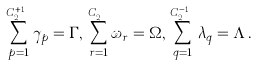<formula> <loc_0><loc_0><loc_500><loc_500>\sum _ { p = 1 } ^ { C _ { 2 N } ^ { x + 1 } } \gamma _ { p } = \Gamma , \, \sum _ { r = 1 } ^ { C _ { 2 N } ^ { x } } \omega _ { r } = \Omega , \, \sum _ { q = 1 } ^ { C _ { 2 N } ^ { x - 1 } } \lambda _ { q } = \Lambda \, .</formula> 